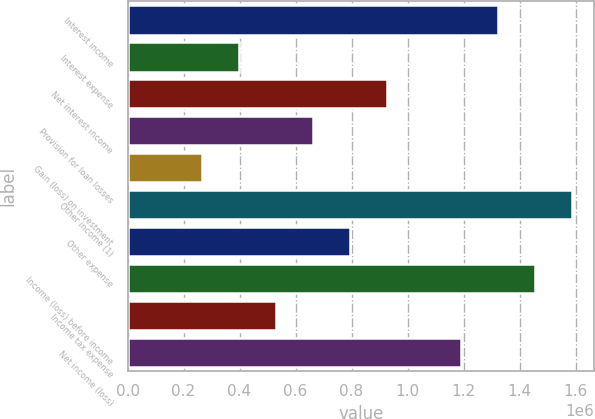<chart> <loc_0><loc_0><loc_500><loc_500><bar_chart><fcel>Interest income<fcel>Interest expense<fcel>Net interest income<fcel>Provision for loan losses<fcel>Gain (loss) on investment<fcel>Other income (1)<fcel>Other expense<fcel>Income (loss) before income<fcel>Income tax expense<fcel>Net income (loss)<nl><fcel>1.32338e+06<fcel>397015<fcel>926368<fcel>661692<fcel>264677<fcel>1.58806e+06<fcel>794030<fcel>1.45572e+06<fcel>529353<fcel>1.19104e+06<nl></chart> 